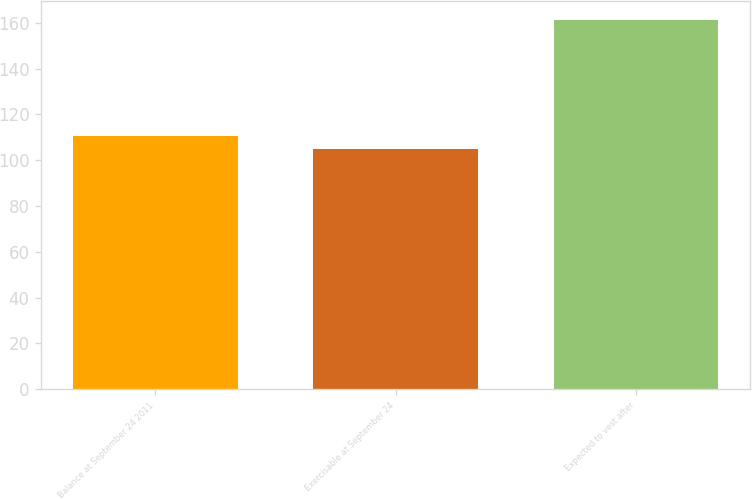Convert chart to OTSL. <chart><loc_0><loc_0><loc_500><loc_500><bar_chart><fcel>Balance at September 24 2011<fcel>Exercisable at September 24<fcel>Expected to vest after<nl><fcel>110.6<fcel>104.97<fcel>161.23<nl></chart> 